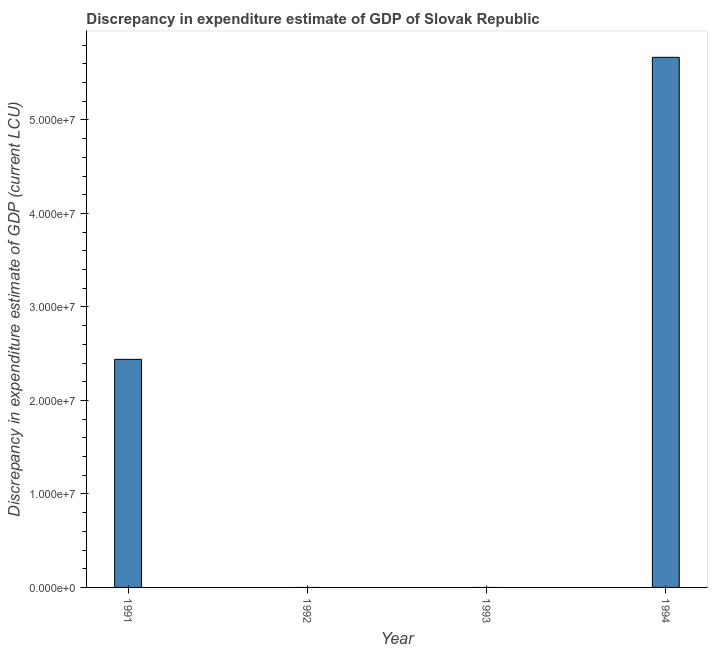Does the graph contain any zero values?
Make the answer very short. Yes. Does the graph contain grids?
Your response must be concise. No. What is the title of the graph?
Provide a short and direct response. Discrepancy in expenditure estimate of GDP of Slovak Republic. What is the label or title of the X-axis?
Your answer should be very brief. Year. What is the label or title of the Y-axis?
Provide a short and direct response. Discrepancy in expenditure estimate of GDP (current LCU). What is the discrepancy in expenditure estimate of gdp in 1993?
Give a very brief answer. 0. Across all years, what is the maximum discrepancy in expenditure estimate of gdp?
Your response must be concise. 5.67e+07. Across all years, what is the minimum discrepancy in expenditure estimate of gdp?
Ensure brevity in your answer.  0. What is the sum of the discrepancy in expenditure estimate of gdp?
Provide a short and direct response. 8.11e+07. What is the average discrepancy in expenditure estimate of gdp per year?
Make the answer very short. 2.03e+07. What is the median discrepancy in expenditure estimate of gdp?
Give a very brief answer. 1.22e+07. In how many years, is the discrepancy in expenditure estimate of gdp greater than 34000000 LCU?
Your answer should be compact. 1. What is the ratio of the discrepancy in expenditure estimate of gdp in 1991 to that in 1994?
Keep it short and to the point. 0.43. What is the difference between the highest and the lowest discrepancy in expenditure estimate of gdp?
Provide a short and direct response. 5.67e+07. In how many years, is the discrepancy in expenditure estimate of gdp greater than the average discrepancy in expenditure estimate of gdp taken over all years?
Give a very brief answer. 2. How many years are there in the graph?
Your answer should be very brief. 4. What is the difference between two consecutive major ticks on the Y-axis?
Offer a very short reply. 1.00e+07. Are the values on the major ticks of Y-axis written in scientific E-notation?
Provide a short and direct response. Yes. What is the Discrepancy in expenditure estimate of GDP (current LCU) of 1991?
Provide a short and direct response. 2.44e+07. What is the Discrepancy in expenditure estimate of GDP (current LCU) in 1992?
Offer a very short reply. 0. What is the Discrepancy in expenditure estimate of GDP (current LCU) in 1993?
Provide a short and direct response. 0. What is the Discrepancy in expenditure estimate of GDP (current LCU) in 1994?
Give a very brief answer. 5.67e+07. What is the difference between the Discrepancy in expenditure estimate of GDP (current LCU) in 1991 and 1994?
Ensure brevity in your answer.  -3.23e+07. What is the ratio of the Discrepancy in expenditure estimate of GDP (current LCU) in 1991 to that in 1994?
Provide a short and direct response. 0.43. 